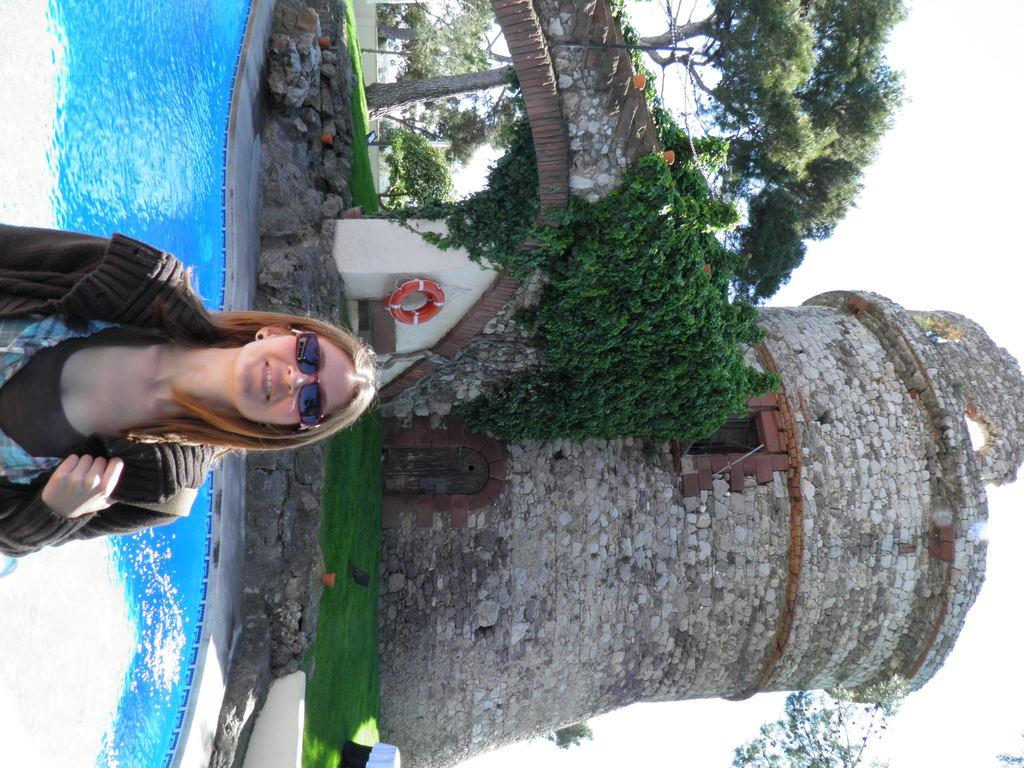What is the person in the image wearing? The person is wearing a brown shirt. What can be seen in the background of the image? There is water, trees, and the sky visible in the image. What color is the water in the image? The water is blue. What color are the trees in the image? The trees are green. What color is the sky in the image? The sky is white. What purpose does the knife serve in the image? There is no knife present in the image, so it cannot serve any purpose. 